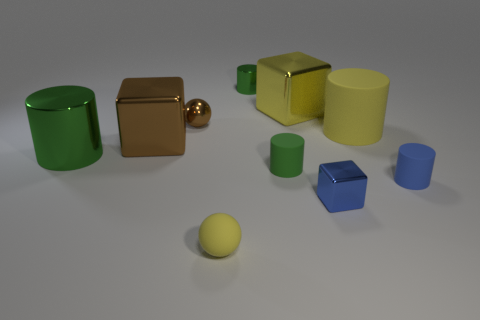Are there any small shiny cylinders that have the same color as the large metal cylinder?
Offer a terse response. Yes. Is the material of the tiny thing behind the small metallic sphere the same as the yellow cylinder to the right of the green matte cylinder?
Offer a terse response. No. What size is the rubber object that is in front of the small blue matte cylinder?
Offer a very short reply. Small. How big is the blue cylinder?
Your answer should be compact. Small. What is the size of the metal block that is in front of the metallic cube on the left side of the tiny green shiny thing behind the green rubber cylinder?
Provide a short and direct response. Small. Are there any small blocks made of the same material as the big yellow block?
Your answer should be compact. Yes. What is the shape of the tiny blue matte thing?
Give a very brief answer. Cylinder. The sphere that is made of the same material as the big yellow cylinder is what color?
Make the answer very short. Yellow. How many green objects are big shiny cubes or big cylinders?
Your response must be concise. 1. Are there more metal cylinders than brown metal spheres?
Offer a terse response. Yes. 